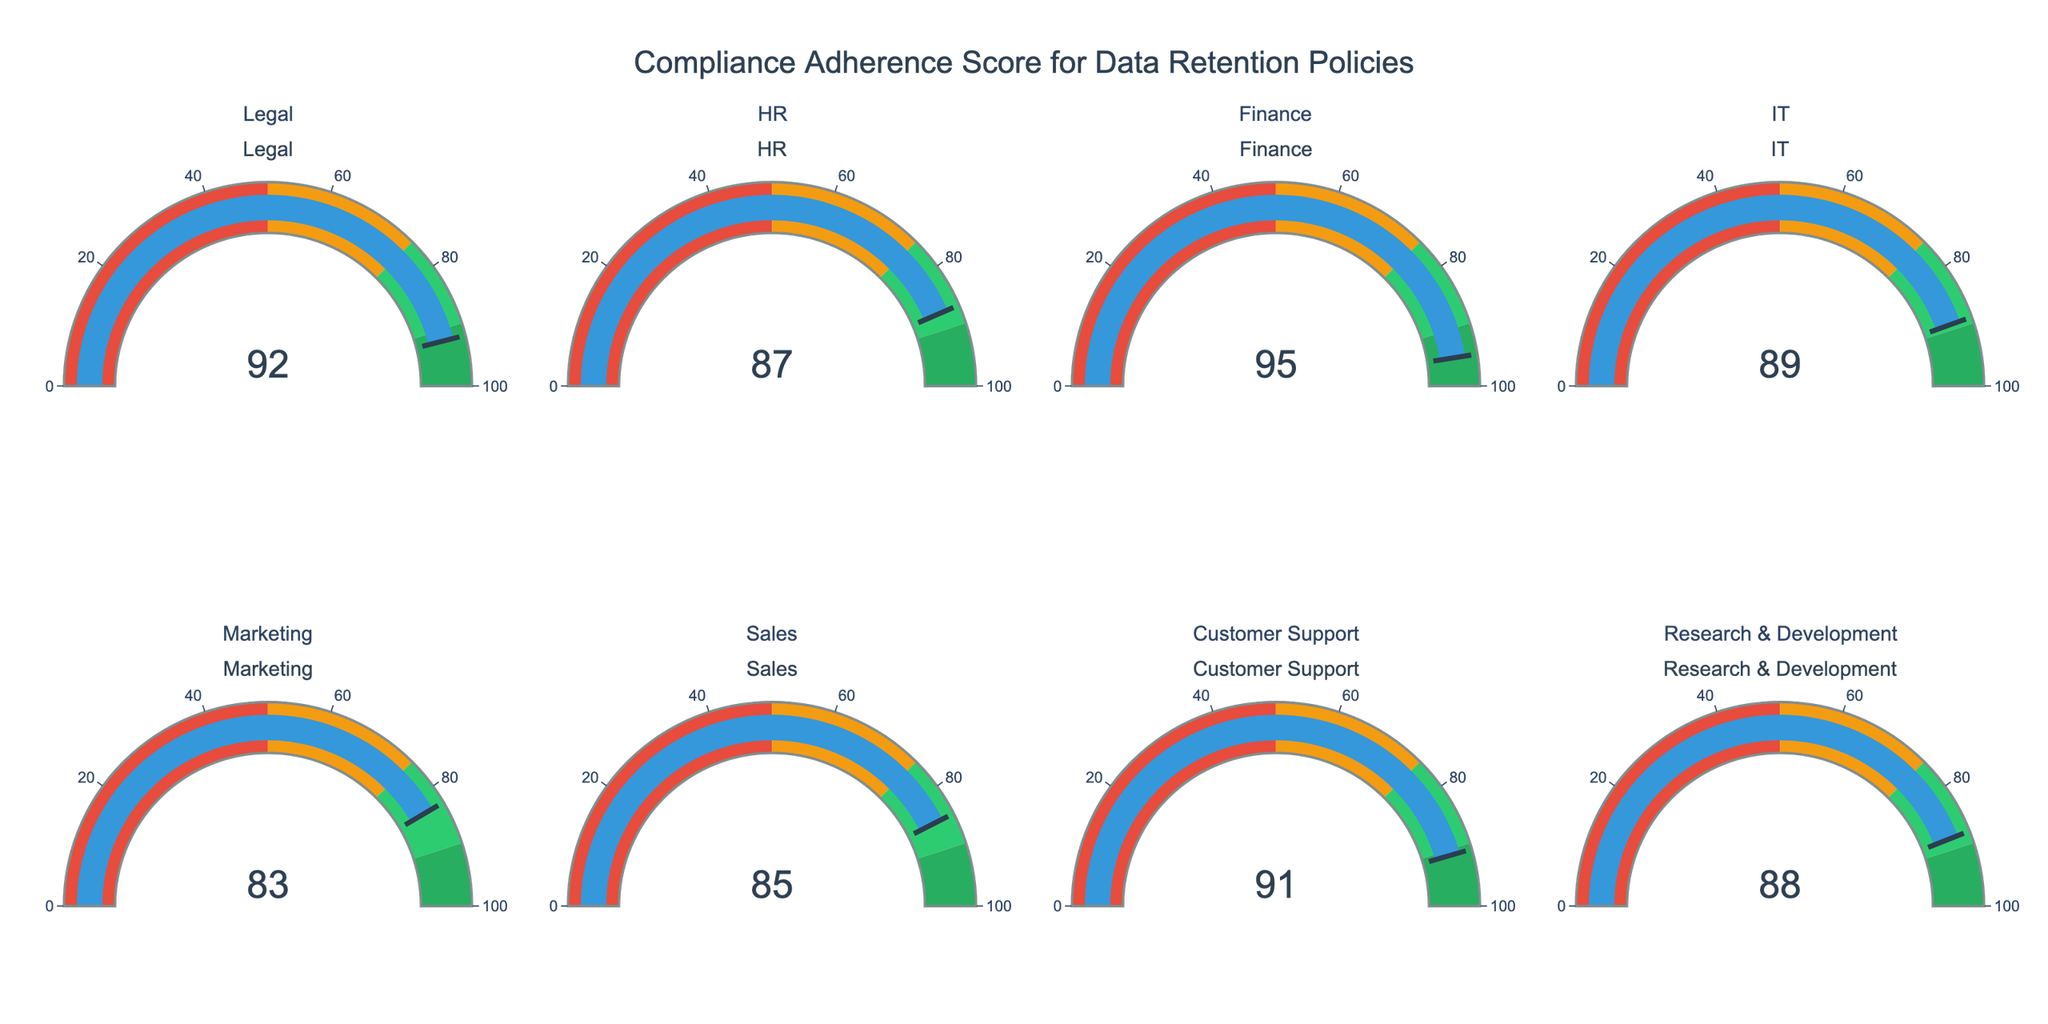What's the title of the figure? The title is usually displayed at the top of the figure. In this case, the title is a text that sums up what the figure represents. The figure title is "Compliance Adherence Score for Data Retention Policies" as indicated in the plotting code.
Answer: Compliance Adherence Score for Data Retention Policies Which department has the highest compliance score? To find this, look at all the individual gauges and identify the highest value. The Finance department has the highest score, which is 95.
Answer: Finance What is the compliance score for the Marketing department? This is a basic question. Locate the gauge labeled "Marketing" and read the number displayed, which is 83.
Answer: 83 What's the median compliance score across all departments? To find the median, first list all the scores: 92, 87, 95, 89, 83, 85, 91, 88. Arrange them in ascending order: 83, 85, 87, 88, 89, 91, 92, 95. The median is the average of the 4th and 5th values, which are 88 and 89. So, the median is (88+89)/2 = 88.5
Answer: 88.5 Which departments have compliance scores greater than 90? Identify all gauges that show a score above 90. The departments are Legal (92), Finance (95), and Customer Support (91).
Answer: Legal, Finance, Customer Support What is the average compliance score of the departments? Sum all the scores: 92 + 87 + 95 + 89 + 83 + 85 + 91 + 88 = 710. Divide by the number of departments, which is 8. So, the average is 710/8 = 88.75
Answer: 88.75 Which two departments have compliance scores that differ by exactly 2 points? Compare the scores to find pairs with a difference of 2. HR (87) and Sales (85) have such a difference.
Answer: HR and Sales Which department has a score closest to 90? Find the scores nearest to 90 and choose the closest one. IT has a score of 89, which is the closest to 90.
Answer: IT How many departments have a compliance score in the range of 80 to 90 inclusive? Count the number of departments whose scores fall within this range: HR (87), IT (89), Marketing (83), Sales (85), and R&D (88). This makes 5 departments.
Answer: 5 List the departments in descending order of their compliance scores Arrange the departments based on their scores from highest to lowest: Finance (95), Legal (92), Customer Support (91), IT (89), Research & Development (88), HR (87), Sales (85), Marketing (83).
Answer: Finance, Legal, Customer Support, IT, Research & Development, HR, Sales, Marketing 